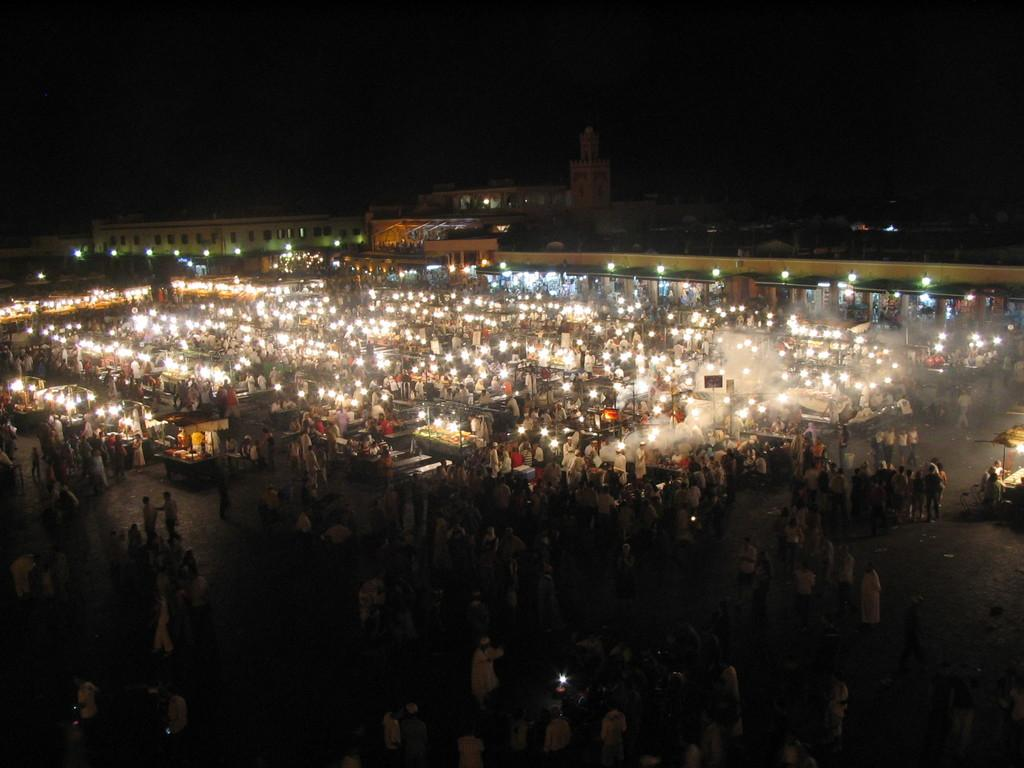What type of location is depicted in the image? The image appears to depict a market. What can be observed about the people in the image? There are many people walking on the road. What can be seen in the sky or at night in the image? There are lights visible in the image. What can be seen in the distance or background of the image? There are buildings in the background of the image. What type of plough is being used by the people in the image? There is no plough present in the image; it depicts a market with people walking on the road. Can you see any guns or weapons in the image? There are no guns or weapons visible in the image. 